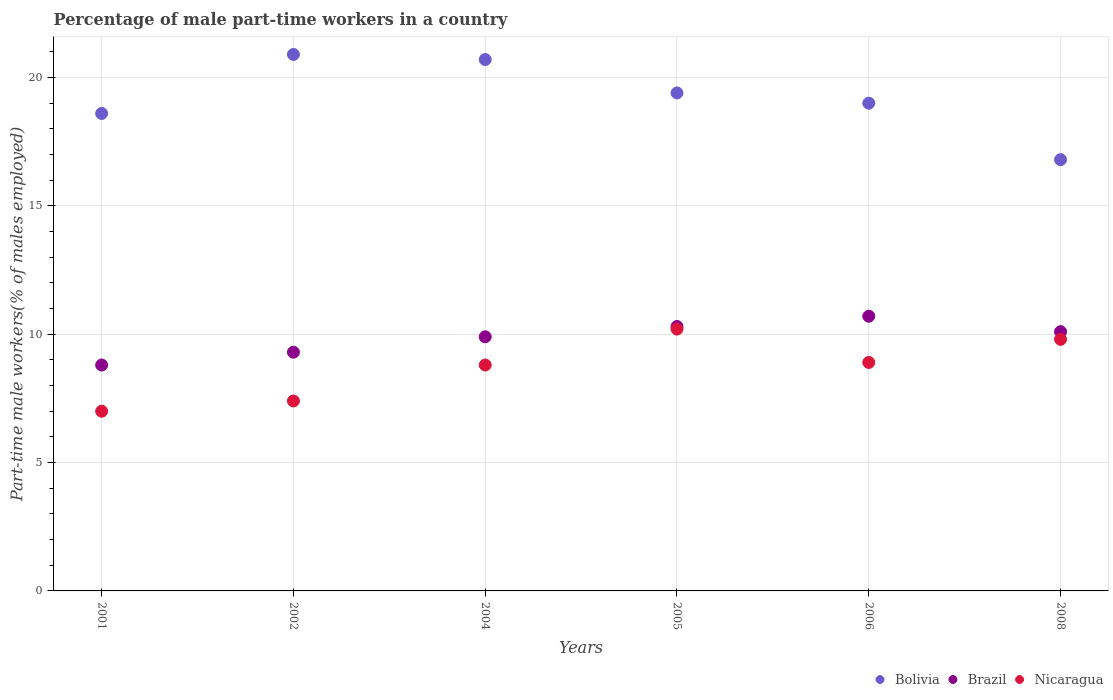How many different coloured dotlines are there?
Your answer should be compact. 3. What is the percentage of male part-time workers in Bolivia in 2001?
Offer a terse response. 18.6. Across all years, what is the maximum percentage of male part-time workers in Brazil?
Offer a very short reply. 10.7. Across all years, what is the minimum percentage of male part-time workers in Bolivia?
Your answer should be very brief. 16.8. In which year was the percentage of male part-time workers in Nicaragua maximum?
Ensure brevity in your answer.  2005. What is the total percentage of male part-time workers in Brazil in the graph?
Your answer should be very brief. 59.1. What is the difference between the percentage of male part-time workers in Brazil in 2002 and that in 2004?
Your answer should be very brief. -0.6. What is the difference between the percentage of male part-time workers in Brazil in 2004 and the percentage of male part-time workers in Bolivia in 2002?
Ensure brevity in your answer.  -11. What is the average percentage of male part-time workers in Bolivia per year?
Make the answer very short. 19.23. In the year 2005, what is the difference between the percentage of male part-time workers in Brazil and percentage of male part-time workers in Nicaragua?
Provide a short and direct response. 0.1. In how many years, is the percentage of male part-time workers in Nicaragua greater than 7 %?
Your response must be concise. 5. What is the ratio of the percentage of male part-time workers in Bolivia in 2005 to that in 2006?
Provide a short and direct response. 1.02. Is the percentage of male part-time workers in Nicaragua in 2001 less than that in 2006?
Ensure brevity in your answer.  Yes. Is the difference between the percentage of male part-time workers in Brazil in 2004 and 2008 greater than the difference between the percentage of male part-time workers in Nicaragua in 2004 and 2008?
Offer a terse response. Yes. What is the difference between the highest and the second highest percentage of male part-time workers in Nicaragua?
Ensure brevity in your answer.  0.4. What is the difference between the highest and the lowest percentage of male part-time workers in Nicaragua?
Offer a terse response. 3.2. Is the sum of the percentage of male part-time workers in Brazil in 2001 and 2006 greater than the maximum percentage of male part-time workers in Nicaragua across all years?
Provide a short and direct response. Yes. Is the percentage of male part-time workers in Bolivia strictly greater than the percentage of male part-time workers in Nicaragua over the years?
Keep it short and to the point. Yes. Is the percentage of male part-time workers in Brazil strictly less than the percentage of male part-time workers in Bolivia over the years?
Give a very brief answer. Yes. How many dotlines are there?
Your answer should be very brief. 3. What is the difference between two consecutive major ticks on the Y-axis?
Offer a very short reply. 5. How are the legend labels stacked?
Your response must be concise. Horizontal. What is the title of the graph?
Offer a very short reply. Percentage of male part-time workers in a country. Does "Luxembourg" appear as one of the legend labels in the graph?
Your answer should be very brief. No. What is the label or title of the X-axis?
Provide a short and direct response. Years. What is the label or title of the Y-axis?
Offer a terse response. Part-time male workers(% of males employed). What is the Part-time male workers(% of males employed) in Bolivia in 2001?
Your response must be concise. 18.6. What is the Part-time male workers(% of males employed) in Brazil in 2001?
Provide a short and direct response. 8.8. What is the Part-time male workers(% of males employed) of Nicaragua in 2001?
Provide a short and direct response. 7. What is the Part-time male workers(% of males employed) in Bolivia in 2002?
Offer a very short reply. 20.9. What is the Part-time male workers(% of males employed) in Brazil in 2002?
Offer a terse response. 9.3. What is the Part-time male workers(% of males employed) of Nicaragua in 2002?
Your response must be concise. 7.4. What is the Part-time male workers(% of males employed) in Bolivia in 2004?
Make the answer very short. 20.7. What is the Part-time male workers(% of males employed) of Brazil in 2004?
Keep it short and to the point. 9.9. What is the Part-time male workers(% of males employed) of Nicaragua in 2004?
Ensure brevity in your answer.  8.8. What is the Part-time male workers(% of males employed) in Bolivia in 2005?
Offer a very short reply. 19.4. What is the Part-time male workers(% of males employed) of Brazil in 2005?
Provide a short and direct response. 10.3. What is the Part-time male workers(% of males employed) in Nicaragua in 2005?
Your answer should be very brief. 10.2. What is the Part-time male workers(% of males employed) in Brazil in 2006?
Offer a terse response. 10.7. What is the Part-time male workers(% of males employed) in Nicaragua in 2006?
Offer a terse response. 8.9. What is the Part-time male workers(% of males employed) of Bolivia in 2008?
Provide a succinct answer. 16.8. What is the Part-time male workers(% of males employed) in Brazil in 2008?
Give a very brief answer. 10.1. What is the Part-time male workers(% of males employed) in Nicaragua in 2008?
Provide a short and direct response. 9.8. Across all years, what is the maximum Part-time male workers(% of males employed) of Bolivia?
Provide a succinct answer. 20.9. Across all years, what is the maximum Part-time male workers(% of males employed) of Brazil?
Give a very brief answer. 10.7. Across all years, what is the maximum Part-time male workers(% of males employed) of Nicaragua?
Offer a terse response. 10.2. Across all years, what is the minimum Part-time male workers(% of males employed) of Bolivia?
Ensure brevity in your answer.  16.8. Across all years, what is the minimum Part-time male workers(% of males employed) in Brazil?
Your response must be concise. 8.8. What is the total Part-time male workers(% of males employed) in Bolivia in the graph?
Offer a very short reply. 115.4. What is the total Part-time male workers(% of males employed) in Brazil in the graph?
Keep it short and to the point. 59.1. What is the total Part-time male workers(% of males employed) in Nicaragua in the graph?
Ensure brevity in your answer.  52.1. What is the difference between the Part-time male workers(% of males employed) of Bolivia in 2001 and that in 2002?
Your answer should be compact. -2.3. What is the difference between the Part-time male workers(% of males employed) in Brazil in 2001 and that in 2002?
Provide a succinct answer. -0.5. What is the difference between the Part-time male workers(% of males employed) of Brazil in 2001 and that in 2004?
Offer a terse response. -1.1. What is the difference between the Part-time male workers(% of males employed) in Nicaragua in 2001 and that in 2004?
Keep it short and to the point. -1.8. What is the difference between the Part-time male workers(% of males employed) of Nicaragua in 2001 and that in 2005?
Make the answer very short. -3.2. What is the difference between the Part-time male workers(% of males employed) of Nicaragua in 2001 and that in 2006?
Offer a terse response. -1.9. What is the difference between the Part-time male workers(% of males employed) in Bolivia in 2001 and that in 2008?
Make the answer very short. 1.8. What is the difference between the Part-time male workers(% of males employed) of Brazil in 2001 and that in 2008?
Give a very brief answer. -1.3. What is the difference between the Part-time male workers(% of males employed) of Nicaragua in 2002 and that in 2004?
Make the answer very short. -1.4. What is the difference between the Part-time male workers(% of males employed) in Bolivia in 2002 and that in 2005?
Make the answer very short. 1.5. What is the difference between the Part-time male workers(% of males employed) in Nicaragua in 2002 and that in 2005?
Your answer should be compact. -2.8. What is the difference between the Part-time male workers(% of males employed) of Bolivia in 2002 and that in 2006?
Make the answer very short. 1.9. What is the difference between the Part-time male workers(% of males employed) of Nicaragua in 2002 and that in 2008?
Your response must be concise. -2.4. What is the difference between the Part-time male workers(% of males employed) in Nicaragua in 2004 and that in 2005?
Offer a very short reply. -1.4. What is the difference between the Part-time male workers(% of males employed) of Brazil in 2004 and that in 2006?
Keep it short and to the point. -0.8. What is the difference between the Part-time male workers(% of males employed) of Bolivia in 2004 and that in 2008?
Your response must be concise. 3.9. What is the difference between the Part-time male workers(% of males employed) in Nicaragua in 2004 and that in 2008?
Your answer should be compact. -1. What is the difference between the Part-time male workers(% of males employed) of Bolivia in 2005 and that in 2006?
Make the answer very short. 0.4. What is the difference between the Part-time male workers(% of males employed) in Brazil in 2005 and that in 2006?
Keep it short and to the point. -0.4. What is the difference between the Part-time male workers(% of males employed) of Nicaragua in 2005 and that in 2008?
Keep it short and to the point. 0.4. What is the difference between the Part-time male workers(% of males employed) of Brazil in 2006 and that in 2008?
Offer a terse response. 0.6. What is the difference between the Part-time male workers(% of males employed) of Bolivia in 2001 and the Part-time male workers(% of males employed) of Brazil in 2002?
Keep it short and to the point. 9.3. What is the difference between the Part-time male workers(% of males employed) of Bolivia in 2001 and the Part-time male workers(% of males employed) of Nicaragua in 2002?
Offer a terse response. 11.2. What is the difference between the Part-time male workers(% of males employed) in Brazil in 2001 and the Part-time male workers(% of males employed) in Nicaragua in 2002?
Ensure brevity in your answer.  1.4. What is the difference between the Part-time male workers(% of males employed) of Bolivia in 2001 and the Part-time male workers(% of males employed) of Brazil in 2004?
Offer a very short reply. 8.7. What is the difference between the Part-time male workers(% of males employed) of Brazil in 2001 and the Part-time male workers(% of males employed) of Nicaragua in 2004?
Ensure brevity in your answer.  0. What is the difference between the Part-time male workers(% of males employed) in Bolivia in 2001 and the Part-time male workers(% of males employed) in Brazil in 2005?
Provide a succinct answer. 8.3. What is the difference between the Part-time male workers(% of males employed) of Bolivia in 2001 and the Part-time male workers(% of males employed) of Nicaragua in 2005?
Keep it short and to the point. 8.4. What is the difference between the Part-time male workers(% of males employed) in Brazil in 2001 and the Part-time male workers(% of males employed) in Nicaragua in 2005?
Your answer should be very brief. -1.4. What is the difference between the Part-time male workers(% of males employed) of Bolivia in 2001 and the Part-time male workers(% of males employed) of Brazil in 2006?
Your response must be concise. 7.9. What is the difference between the Part-time male workers(% of males employed) of Bolivia in 2001 and the Part-time male workers(% of males employed) of Nicaragua in 2008?
Your response must be concise. 8.8. What is the difference between the Part-time male workers(% of males employed) in Bolivia in 2002 and the Part-time male workers(% of males employed) in Nicaragua in 2004?
Make the answer very short. 12.1. What is the difference between the Part-time male workers(% of males employed) of Brazil in 2002 and the Part-time male workers(% of males employed) of Nicaragua in 2004?
Make the answer very short. 0.5. What is the difference between the Part-time male workers(% of males employed) of Bolivia in 2002 and the Part-time male workers(% of males employed) of Nicaragua in 2005?
Your response must be concise. 10.7. What is the difference between the Part-time male workers(% of males employed) of Brazil in 2002 and the Part-time male workers(% of males employed) of Nicaragua in 2005?
Your answer should be compact. -0.9. What is the difference between the Part-time male workers(% of males employed) in Bolivia in 2002 and the Part-time male workers(% of males employed) in Brazil in 2006?
Your response must be concise. 10.2. What is the difference between the Part-time male workers(% of males employed) in Bolivia in 2002 and the Part-time male workers(% of males employed) in Nicaragua in 2006?
Provide a short and direct response. 12. What is the difference between the Part-time male workers(% of males employed) of Brazil in 2002 and the Part-time male workers(% of males employed) of Nicaragua in 2006?
Ensure brevity in your answer.  0.4. What is the difference between the Part-time male workers(% of males employed) of Bolivia in 2002 and the Part-time male workers(% of males employed) of Brazil in 2008?
Provide a succinct answer. 10.8. What is the difference between the Part-time male workers(% of males employed) in Brazil in 2002 and the Part-time male workers(% of males employed) in Nicaragua in 2008?
Provide a short and direct response. -0.5. What is the difference between the Part-time male workers(% of males employed) in Bolivia in 2004 and the Part-time male workers(% of males employed) in Brazil in 2005?
Your answer should be very brief. 10.4. What is the difference between the Part-time male workers(% of males employed) of Bolivia in 2004 and the Part-time male workers(% of males employed) of Nicaragua in 2005?
Provide a short and direct response. 10.5. What is the difference between the Part-time male workers(% of males employed) in Brazil in 2004 and the Part-time male workers(% of males employed) in Nicaragua in 2005?
Your response must be concise. -0.3. What is the difference between the Part-time male workers(% of males employed) in Bolivia in 2004 and the Part-time male workers(% of males employed) in Brazil in 2006?
Give a very brief answer. 10. What is the difference between the Part-time male workers(% of males employed) of Bolivia in 2004 and the Part-time male workers(% of males employed) of Nicaragua in 2006?
Provide a short and direct response. 11.8. What is the difference between the Part-time male workers(% of males employed) of Brazil in 2004 and the Part-time male workers(% of males employed) of Nicaragua in 2006?
Ensure brevity in your answer.  1. What is the difference between the Part-time male workers(% of males employed) of Bolivia in 2004 and the Part-time male workers(% of males employed) of Brazil in 2008?
Ensure brevity in your answer.  10.6. What is the difference between the Part-time male workers(% of males employed) of Bolivia in 2005 and the Part-time male workers(% of males employed) of Brazil in 2006?
Your answer should be compact. 8.7. What is the difference between the Part-time male workers(% of males employed) in Brazil in 2005 and the Part-time male workers(% of males employed) in Nicaragua in 2008?
Provide a short and direct response. 0.5. What is the difference between the Part-time male workers(% of males employed) in Bolivia in 2006 and the Part-time male workers(% of males employed) in Brazil in 2008?
Offer a terse response. 8.9. What is the difference between the Part-time male workers(% of males employed) of Bolivia in 2006 and the Part-time male workers(% of males employed) of Nicaragua in 2008?
Provide a short and direct response. 9.2. What is the difference between the Part-time male workers(% of males employed) of Brazil in 2006 and the Part-time male workers(% of males employed) of Nicaragua in 2008?
Offer a very short reply. 0.9. What is the average Part-time male workers(% of males employed) in Bolivia per year?
Make the answer very short. 19.23. What is the average Part-time male workers(% of males employed) of Brazil per year?
Provide a succinct answer. 9.85. What is the average Part-time male workers(% of males employed) in Nicaragua per year?
Provide a short and direct response. 8.68. In the year 2002, what is the difference between the Part-time male workers(% of males employed) of Bolivia and Part-time male workers(% of males employed) of Nicaragua?
Offer a very short reply. 13.5. In the year 2004, what is the difference between the Part-time male workers(% of males employed) in Bolivia and Part-time male workers(% of males employed) in Nicaragua?
Provide a succinct answer. 11.9. In the year 2005, what is the difference between the Part-time male workers(% of males employed) of Bolivia and Part-time male workers(% of males employed) of Brazil?
Your response must be concise. 9.1. In the year 2005, what is the difference between the Part-time male workers(% of males employed) in Brazil and Part-time male workers(% of males employed) in Nicaragua?
Your answer should be very brief. 0.1. In the year 2006, what is the difference between the Part-time male workers(% of males employed) of Bolivia and Part-time male workers(% of males employed) of Brazil?
Your response must be concise. 8.3. In the year 2006, what is the difference between the Part-time male workers(% of males employed) in Bolivia and Part-time male workers(% of males employed) in Nicaragua?
Provide a succinct answer. 10.1. What is the ratio of the Part-time male workers(% of males employed) of Bolivia in 2001 to that in 2002?
Provide a short and direct response. 0.89. What is the ratio of the Part-time male workers(% of males employed) in Brazil in 2001 to that in 2002?
Ensure brevity in your answer.  0.95. What is the ratio of the Part-time male workers(% of males employed) in Nicaragua in 2001 to that in 2002?
Make the answer very short. 0.95. What is the ratio of the Part-time male workers(% of males employed) of Bolivia in 2001 to that in 2004?
Offer a terse response. 0.9. What is the ratio of the Part-time male workers(% of males employed) in Brazil in 2001 to that in 2004?
Provide a short and direct response. 0.89. What is the ratio of the Part-time male workers(% of males employed) in Nicaragua in 2001 to that in 2004?
Provide a short and direct response. 0.8. What is the ratio of the Part-time male workers(% of males employed) of Bolivia in 2001 to that in 2005?
Your answer should be compact. 0.96. What is the ratio of the Part-time male workers(% of males employed) in Brazil in 2001 to that in 2005?
Offer a terse response. 0.85. What is the ratio of the Part-time male workers(% of males employed) of Nicaragua in 2001 to that in 2005?
Offer a very short reply. 0.69. What is the ratio of the Part-time male workers(% of males employed) of Bolivia in 2001 to that in 2006?
Your answer should be very brief. 0.98. What is the ratio of the Part-time male workers(% of males employed) of Brazil in 2001 to that in 2006?
Your answer should be compact. 0.82. What is the ratio of the Part-time male workers(% of males employed) of Nicaragua in 2001 to that in 2006?
Provide a succinct answer. 0.79. What is the ratio of the Part-time male workers(% of males employed) in Bolivia in 2001 to that in 2008?
Offer a terse response. 1.11. What is the ratio of the Part-time male workers(% of males employed) of Brazil in 2001 to that in 2008?
Ensure brevity in your answer.  0.87. What is the ratio of the Part-time male workers(% of males employed) in Bolivia in 2002 to that in 2004?
Offer a terse response. 1.01. What is the ratio of the Part-time male workers(% of males employed) of Brazil in 2002 to that in 2004?
Offer a very short reply. 0.94. What is the ratio of the Part-time male workers(% of males employed) of Nicaragua in 2002 to that in 2004?
Ensure brevity in your answer.  0.84. What is the ratio of the Part-time male workers(% of males employed) in Bolivia in 2002 to that in 2005?
Give a very brief answer. 1.08. What is the ratio of the Part-time male workers(% of males employed) in Brazil in 2002 to that in 2005?
Your response must be concise. 0.9. What is the ratio of the Part-time male workers(% of males employed) in Nicaragua in 2002 to that in 2005?
Your answer should be very brief. 0.73. What is the ratio of the Part-time male workers(% of males employed) in Brazil in 2002 to that in 2006?
Give a very brief answer. 0.87. What is the ratio of the Part-time male workers(% of males employed) in Nicaragua in 2002 to that in 2006?
Your answer should be compact. 0.83. What is the ratio of the Part-time male workers(% of males employed) of Bolivia in 2002 to that in 2008?
Your response must be concise. 1.24. What is the ratio of the Part-time male workers(% of males employed) in Brazil in 2002 to that in 2008?
Your answer should be compact. 0.92. What is the ratio of the Part-time male workers(% of males employed) in Nicaragua in 2002 to that in 2008?
Offer a very short reply. 0.76. What is the ratio of the Part-time male workers(% of males employed) in Bolivia in 2004 to that in 2005?
Your answer should be compact. 1.07. What is the ratio of the Part-time male workers(% of males employed) in Brazil in 2004 to that in 2005?
Make the answer very short. 0.96. What is the ratio of the Part-time male workers(% of males employed) of Nicaragua in 2004 to that in 2005?
Provide a succinct answer. 0.86. What is the ratio of the Part-time male workers(% of males employed) in Bolivia in 2004 to that in 2006?
Your answer should be very brief. 1.09. What is the ratio of the Part-time male workers(% of males employed) in Brazil in 2004 to that in 2006?
Your answer should be very brief. 0.93. What is the ratio of the Part-time male workers(% of males employed) of Nicaragua in 2004 to that in 2006?
Provide a short and direct response. 0.99. What is the ratio of the Part-time male workers(% of males employed) of Bolivia in 2004 to that in 2008?
Give a very brief answer. 1.23. What is the ratio of the Part-time male workers(% of males employed) of Brazil in 2004 to that in 2008?
Ensure brevity in your answer.  0.98. What is the ratio of the Part-time male workers(% of males employed) of Nicaragua in 2004 to that in 2008?
Keep it short and to the point. 0.9. What is the ratio of the Part-time male workers(% of males employed) in Bolivia in 2005 to that in 2006?
Ensure brevity in your answer.  1.02. What is the ratio of the Part-time male workers(% of males employed) of Brazil in 2005 to that in 2006?
Your answer should be very brief. 0.96. What is the ratio of the Part-time male workers(% of males employed) of Nicaragua in 2005 to that in 2006?
Give a very brief answer. 1.15. What is the ratio of the Part-time male workers(% of males employed) in Bolivia in 2005 to that in 2008?
Offer a terse response. 1.15. What is the ratio of the Part-time male workers(% of males employed) in Brazil in 2005 to that in 2008?
Your answer should be very brief. 1.02. What is the ratio of the Part-time male workers(% of males employed) in Nicaragua in 2005 to that in 2008?
Offer a terse response. 1.04. What is the ratio of the Part-time male workers(% of males employed) of Bolivia in 2006 to that in 2008?
Your answer should be very brief. 1.13. What is the ratio of the Part-time male workers(% of males employed) in Brazil in 2006 to that in 2008?
Provide a succinct answer. 1.06. What is the ratio of the Part-time male workers(% of males employed) of Nicaragua in 2006 to that in 2008?
Offer a terse response. 0.91. What is the difference between the highest and the second highest Part-time male workers(% of males employed) of Bolivia?
Your answer should be compact. 0.2. What is the difference between the highest and the lowest Part-time male workers(% of males employed) of Bolivia?
Provide a short and direct response. 4.1. What is the difference between the highest and the lowest Part-time male workers(% of males employed) in Brazil?
Your response must be concise. 1.9. What is the difference between the highest and the lowest Part-time male workers(% of males employed) in Nicaragua?
Offer a terse response. 3.2. 